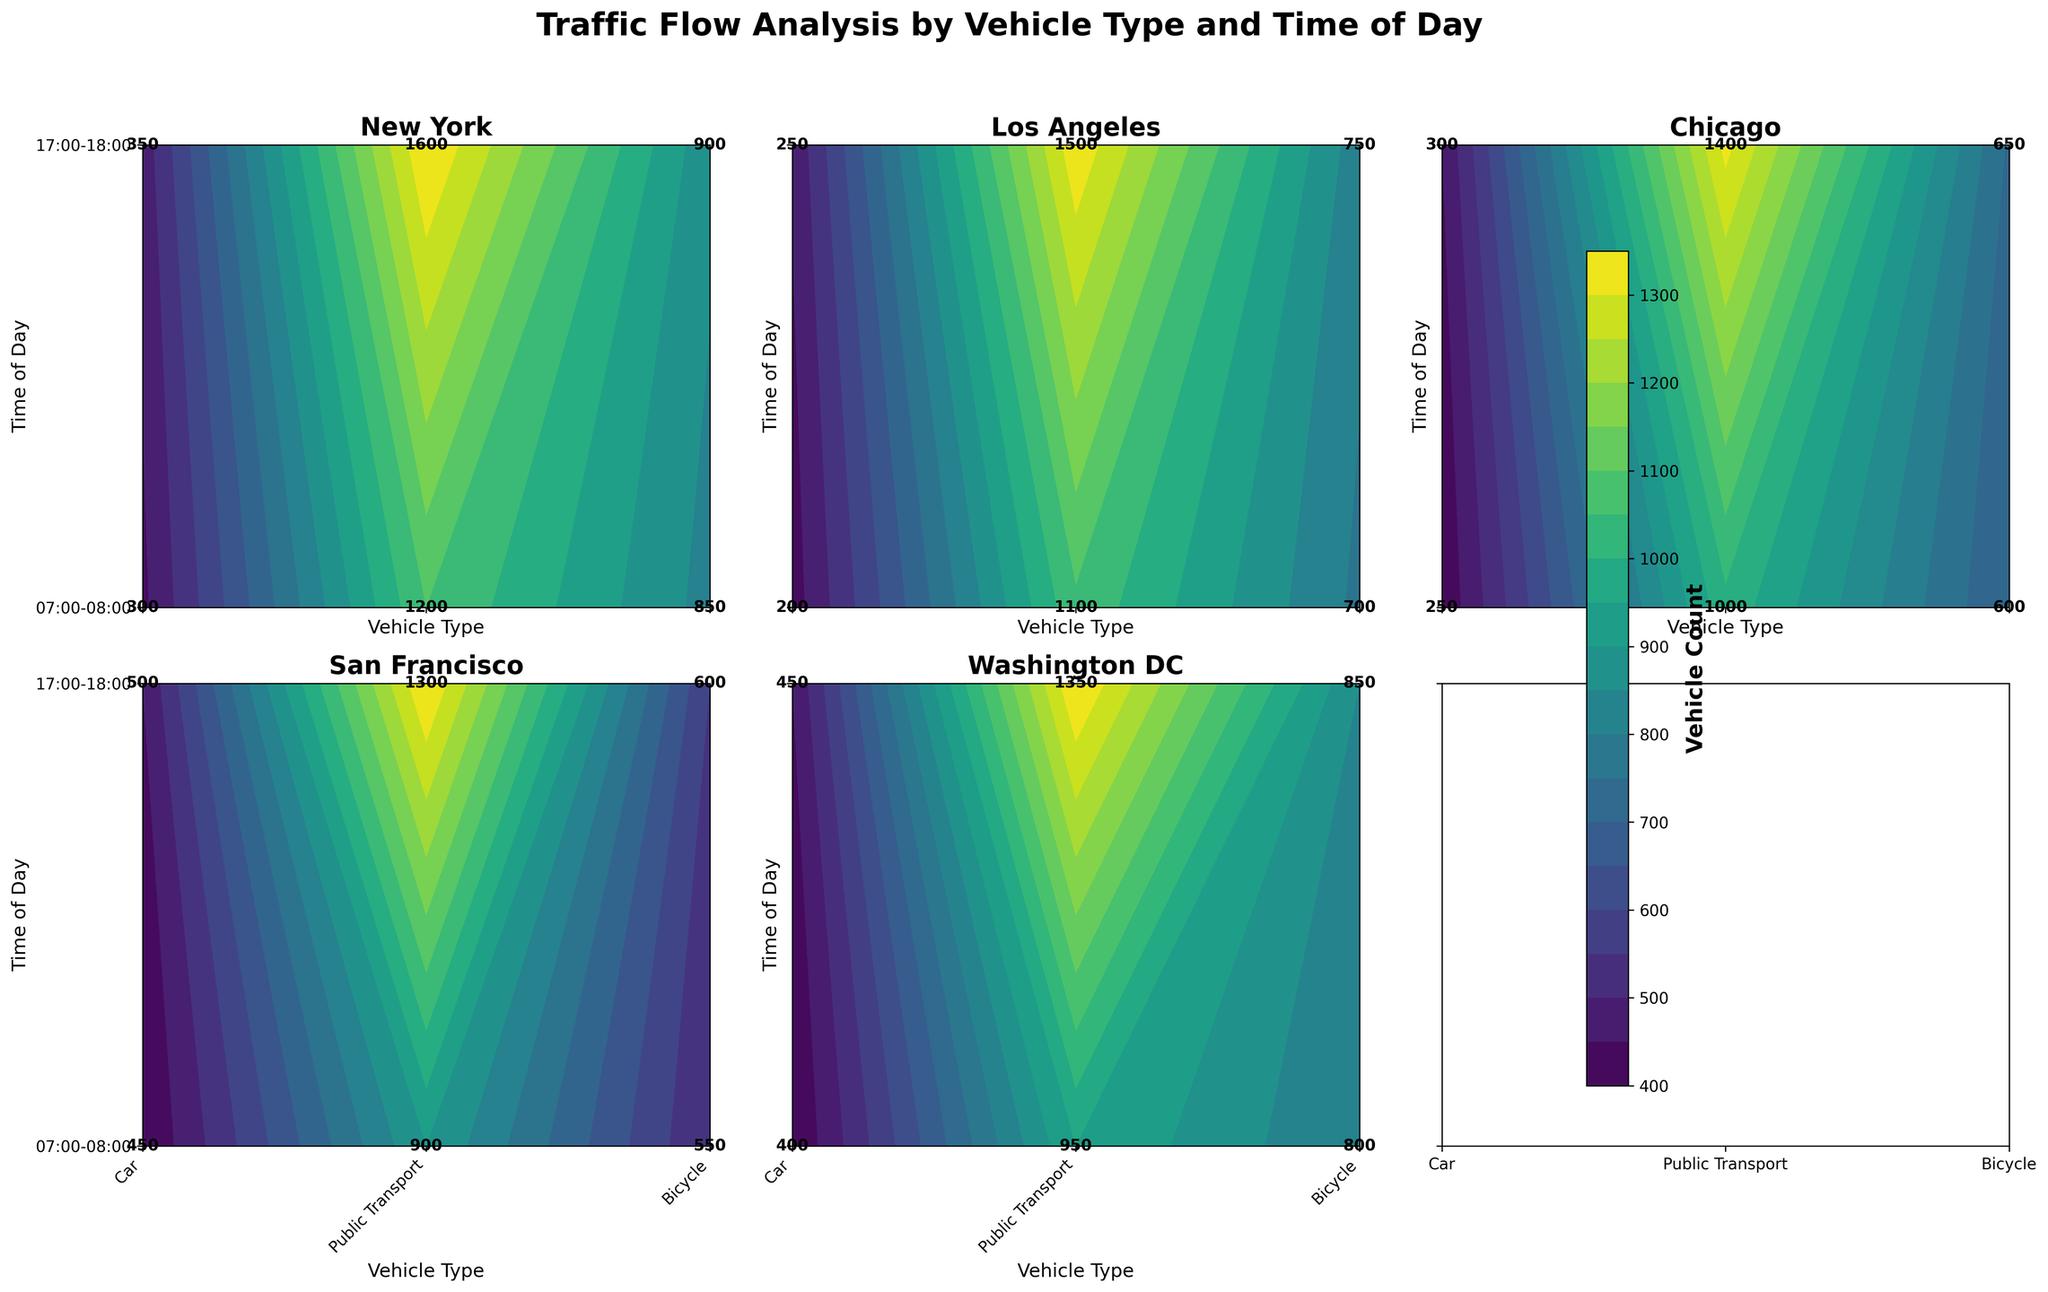How many location subplots are there in the figure? The figure consists of subplots for each location listed in the dataset. There are 5 locations: New York, Los Angeles, Chicago, San Francisco, and Washington DC.
Answer: 5 Which location has the highest vehicle count for cars during 17:00-18:00? To find the location with the highest vehicle count for cars during 17:00-18:00, you need to compare the values in the 'Car' columns under the 17:00-18:00 row across all subplots. The highest count is 1600, found in the New York subplot.
Answer: New York What is the average bicycle count during 07:00-08:00 across all locations? Add up the bicycle counts for 07:00-08:00 for all locations and then divide by the number of locations (5). The counts are 300, 200, 250, 450, and 400. The total is 1600, and the average is 1600 / 5.
Answer: 320 Which type of vehicle has the least count in San Francisco during 07:00-08:00? Look at the San Francisco subplot and compare the counts for each vehicle type during 07:00-08:00. The counts are 900 (Car), 550 (Public Transport), and 450 (Bicycle). The least count is for Public Transport with 550.
Answer: Public Transport How does the total vehicle count for bicycles compare between the two time slots in Washington DC? Check the counts for bicycles during 07:00-08:00 and 17:00-18:00 in the Washington DC subplot. The counts are 400 and 450, respectively. The 17:00-18:00 slot has 50 more bicycles.
Answer: 17:00-18:00 has more bicycles Which time of day generally has higher public transport usage in Los Angeles? Compare the counts of public transport for the two time slots in the Los Angeles subplot. The counts are 700 during 07:00-08:00 and 750 during 17:00-18:00. The evening slot has a higher count.
Answer: 17:00-18:00 What is the overall vehicle distribution like in Chicago between the two times? Analyze the Chicago subplot by adding all vehicle counts for both time slots. For 07:00-08:00: 1000 (Cars) + 600 (Public Transport) + 250 (Bicycles) = 1850. For 17:00-18:00: 1400 (Cars) + 650 (Public Transport) + 300 (Bicycles) = 2350. The latter has more vehicles.
Answer: 17:00-18:00 has more overall vehicles Is there any city where the car count is the lowest among all vehicle types during any of the time slots? For each city's subplot, check if the car count is lower than both public transport and bicycle counts for any given time slot. None of the cities show cars having the lowest count.
Answer: No Which vehicle type shows the most consistent counts across all locations and times? Check each subplot to determine which vehicle type has the smallest range of counts across all locations and times. Cars have counts that vary more, while bicycles are the most consistent with counts generally around 200-500.
Answer: Bicycles 